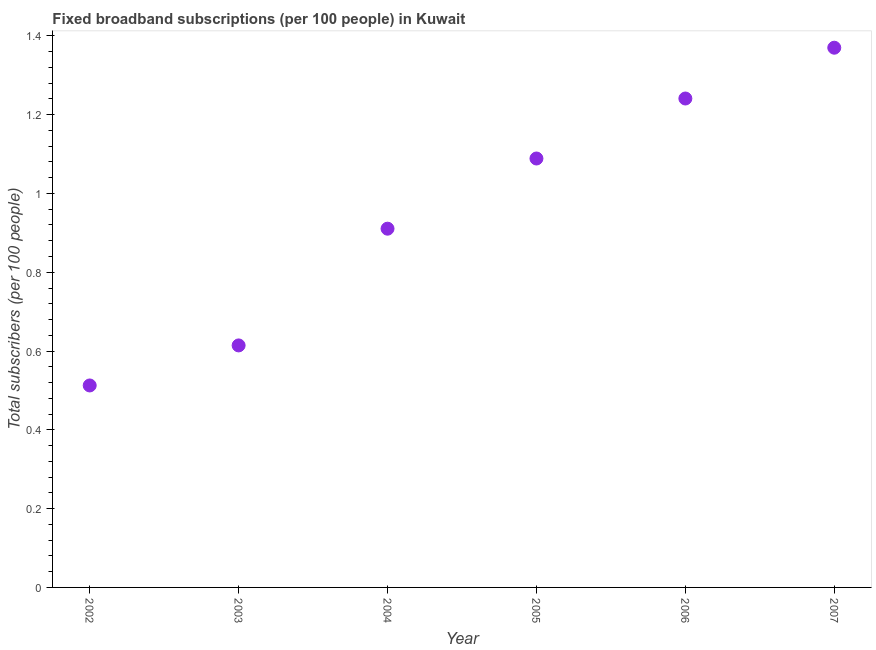What is the total number of fixed broadband subscriptions in 2006?
Your answer should be very brief. 1.24. Across all years, what is the maximum total number of fixed broadband subscriptions?
Your response must be concise. 1.37. Across all years, what is the minimum total number of fixed broadband subscriptions?
Offer a very short reply. 0.51. What is the sum of the total number of fixed broadband subscriptions?
Your response must be concise. 5.74. What is the difference between the total number of fixed broadband subscriptions in 2003 and 2005?
Provide a short and direct response. -0.47. What is the average total number of fixed broadband subscriptions per year?
Offer a terse response. 0.96. What is the median total number of fixed broadband subscriptions?
Make the answer very short. 1. In how many years, is the total number of fixed broadband subscriptions greater than 0.9600000000000001 ?
Make the answer very short. 3. Do a majority of the years between 2007 and 2004 (inclusive) have total number of fixed broadband subscriptions greater than 0.52 ?
Keep it short and to the point. Yes. What is the ratio of the total number of fixed broadband subscriptions in 2003 to that in 2005?
Your answer should be very brief. 0.56. What is the difference between the highest and the second highest total number of fixed broadband subscriptions?
Give a very brief answer. 0.13. What is the difference between the highest and the lowest total number of fixed broadband subscriptions?
Your answer should be compact. 0.86. In how many years, is the total number of fixed broadband subscriptions greater than the average total number of fixed broadband subscriptions taken over all years?
Your answer should be compact. 3. How many years are there in the graph?
Your response must be concise. 6. Are the values on the major ticks of Y-axis written in scientific E-notation?
Give a very brief answer. No. What is the title of the graph?
Your response must be concise. Fixed broadband subscriptions (per 100 people) in Kuwait. What is the label or title of the X-axis?
Your answer should be very brief. Year. What is the label or title of the Y-axis?
Keep it short and to the point. Total subscribers (per 100 people). What is the Total subscribers (per 100 people) in 2002?
Ensure brevity in your answer.  0.51. What is the Total subscribers (per 100 people) in 2003?
Provide a succinct answer. 0.61. What is the Total subscribers (per 100 people) in 2004?
Provide a succinct answer. 0.91. What is the Total subscribers (per 100 people) in 2005?
Provide a short and direct response. 1.09. What is the Total subscribers (per 100 people) in 2006?
Ensure brevity in your answer.  1.24. What is the Total subscribers (per 100 people) in 2007?
Your answer should be very brief. 1.37. What is the difference between the Total subscribers (per 100 people) in 2002 and 2003?
Give a very brief answer. -0.1. What is the difference between the Total subscribers (per 100 people) in 2002 and 2004?
Ensure brevity in your answer.  -0.4. What is the difference between the Total subscribers (per 100 people) in 2002 and 2005?
Give a very brief answer. -0.58. What is the difference between the Total subscribers (per 100 people) in 2002 and 2006?
Offer a terse response. -0.73. What is the difference between the Total subscribers (per 100 people) in 2002 and 2007?
Give a very brief answer. -0.86. What is the difference between the Total subscribers (per 100 people) in 2003 and 2004?
Your answer should be very brief. -0.3. What is the difference between the Total subscribers (per 100 people) in 2003 and 2005?
Keep it short and to the point. -0.47. What is the difference between the Total subscribers (per 100 people) in 2003 and 2006?
Keep it short and to the point. -0.63. What is the difference between the Total subscribers (per 100 people) in 2003 and 2007?
Your answer should be compact. -0.76. What is the difference between the Total subscribers (per 100 people) in 2004 and 2005?
Ensure brevity in your answer.  -0.18. What is the difference between the Total subscribers (per 100 people) in 2004 and 2006?
Provide a succinct answer. -0.33. What is the difference between the Total subscribers (per 100 people) in 2004 and 2007?
Keep it short and to the point. -0.46. What is the difference between the Total subscribers (per 100 people) in 2005 and 2006?
Keep it short and to the point. -0.15. What is the difference between the Total subscribers (per 100 people) in 2005 and 2007?
Your response must be concise. -0.28. What is the difference between the Total subscribers (per 100 people) in 2006 and 2007?
Make the answer very short. -0.13. What is the ratio of the Total subscribers (per 100 people) in 2002 to that in 2003?
Keep it short and to the point. 0.83. What is the ratio of the Total subscribers (per 100 people) in 2002 to that in 2004?
Provide a succinct answer. 0.56. What is the ratio of the Total subscribers (per 100 people) in 2002 to that in 2005?
Give a very brief answer. 0.47. What is the ratio of the Total subscribers (per 100 people) in 2002 to that in 2006?
Provide a succinct answer. 0.41. What is the ratio of the Total subscribers (per 100 people) in 2002 to that in 2007?
Ensure brevity in your answer.  0.37. What is the ratio of the Total subscribers (per 100 people) in 2003 to that in 2004?
Provide a short and direct response. 0.68. What is the ratio of the Total subscribers (per 100 people) in 2003 to that in 2005?
Your answer should be very brief. 0.56. What is the ratio of the Total subscribers (per 100 people) in 2003 to that in 2006?
Provide a succinct answer. 0.49. What is the ratio of the Total subscribers (per 100 people) in 2003 to that in 2007?
Provide a succinct answer. 0.45. What is the ratio of the Total subscribers (per 100 people) in 2004 to that in 2005?
Provide a short and direct response. 0.84. What is the ratio of the Total subscribers (per 100 people) in 2004 to that in 2006?
Ensure brevity in your answer.  0.73. What is the ratio of the Total subscribers (per 100 people) in 2004 to that in 2007?
Make the answer very short. 0.67. What is the ratio of the Total subscribers (per 100 people) in 2005 to that in 2006?
Your answer should be compact. 0.88. What is the ratio of the Total subscribers (per 100 people) in 2005 to that in 2007?
Provide a succinct answer. 0.8. What is the ratio of the Total subscribers (per 100 people) in 2006 to that in 2007?
Ensure brevity in your answer.  0.91. 